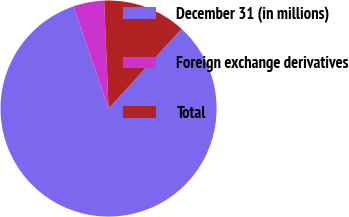<chart> <loc_0><loc_0><loc_500><loc_500><pie_chart><fcel>December 31 (in millions)<fcel>Foreign exchange derivatives<fcel>Total<nl><fcel>82.92%<fcel>4.62%<fcel>12.45%<nl></chart> 